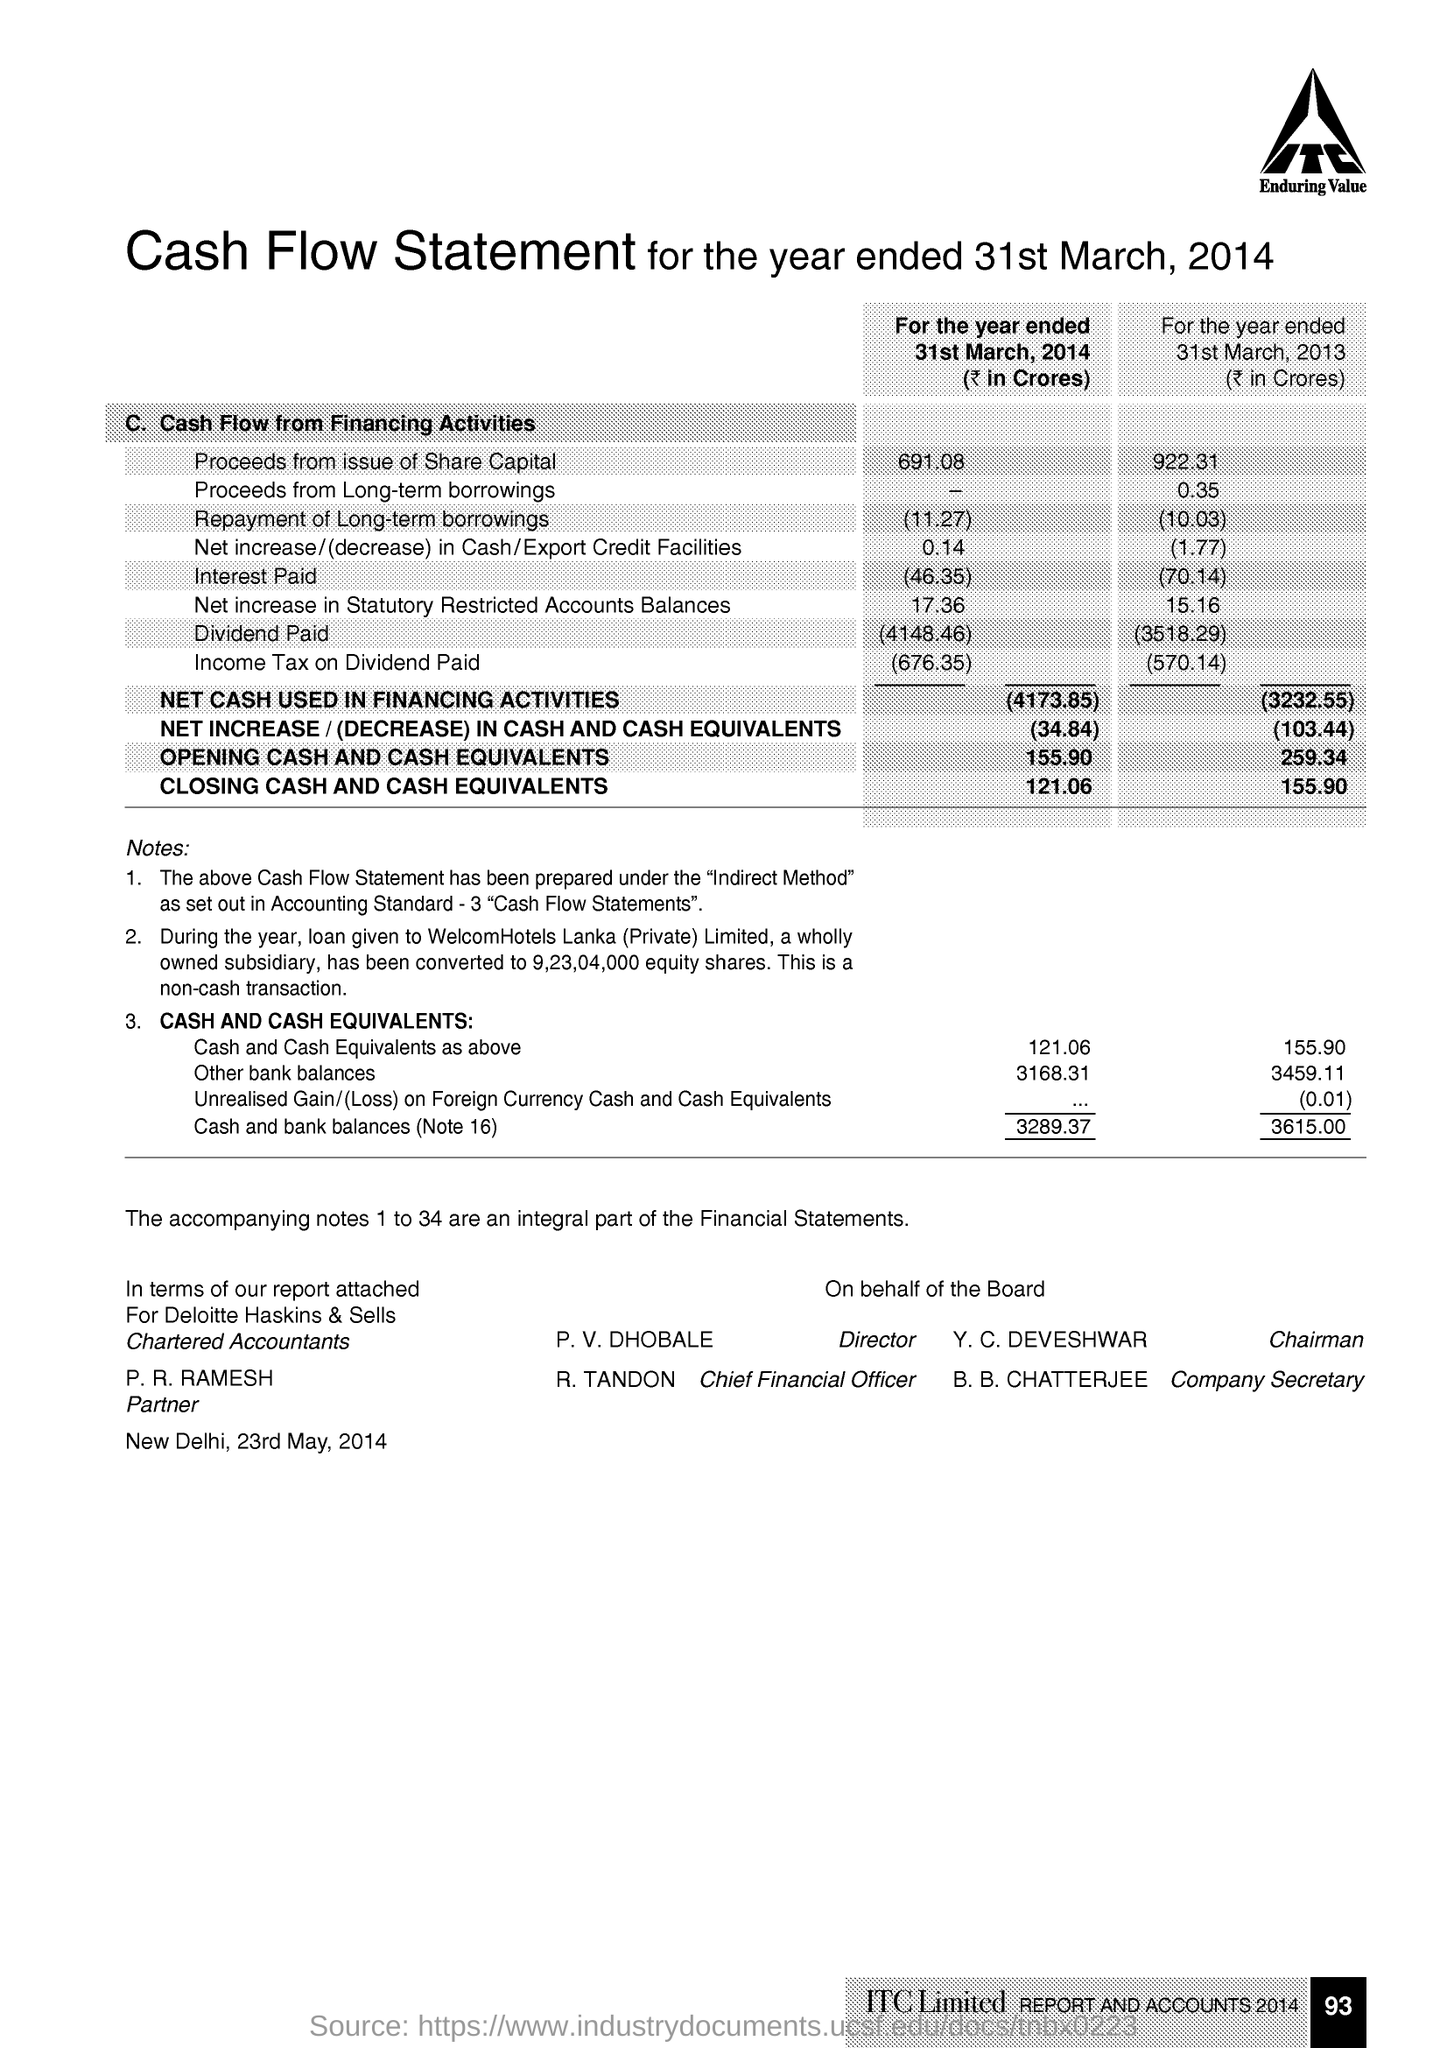Who is the Chairman of the Company ?
Your answer should be compact. Y. C. DEVESHWAR. Who is the director of the Company ?
Provide a short and direct response. P. V. DHOBALE. Who is the Company Secretary ?
Your response must be concise. B. B. CHATTERJEE. Who is the Chief Financial Officer ?
Provide a succinct answer. R. TANDON. 